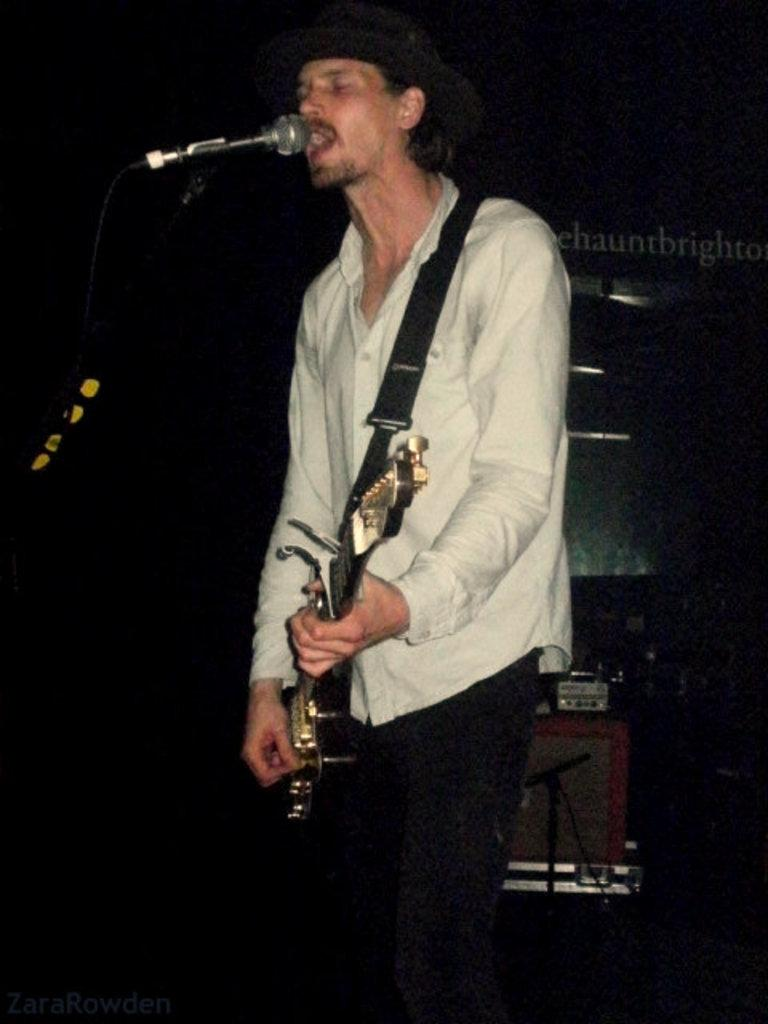What is the main subject of the image? There is a man in the image. What is the man doing in the image? The man is standing, playing a guitar, and singing into a microphone. What type of church can be seen in the background of the image? There is no church visible in the image; it only features a man playing a guitar and singing into a microphone. How many giants are present in the image? There are no giants present in the image; it only features a man playing a guitar and singing into a microphone. 